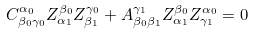<formula> <loc_0><loc_0><loc_500><loc_500>C ^ { \alpha _ { 0 } } _ { \beta _ { 0 } \gamma _ { 0 } } Z ^ { \beta _ { 0 } } _ { \alpha _ { 1 } } Z ^ { \gamma _ { 0 } } _ { \beta _ { 1 } } + A ^ { \gamma _ { 1 } } _ { \beta _ { 0 } \beta _ { 1 } } Z ^ { \beta _ { 0 } } _ { \alpha _ { 1 } } Z ^ { \alpha _ { 0 } } _ { \gamma _ { 1 } } = 0</formula> 